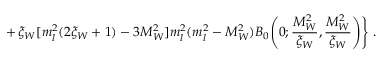Convert formula to latex. <formula><loc_0><loc_0><loc_500><loc_500>+ \, \xi _ { W } [ m _ { l } ^ { 2 } ( 2 \xi _ { W } + 1 ) - 3 M _ { W } ^ { 2 } ] m _ { l } ^ { 2 } ( m _ { l } ^ { 2 } - M _ { W } ^ { 2 } ) B _ { 0 } \Big ( 0 ; \frac { M _ { W } ^ { 2 } } { \xi _ { W } } , \frac { M _ { W } ^ { 2 } } { \xi _ { W } } \Big ) \Big \} \ .</formula> 